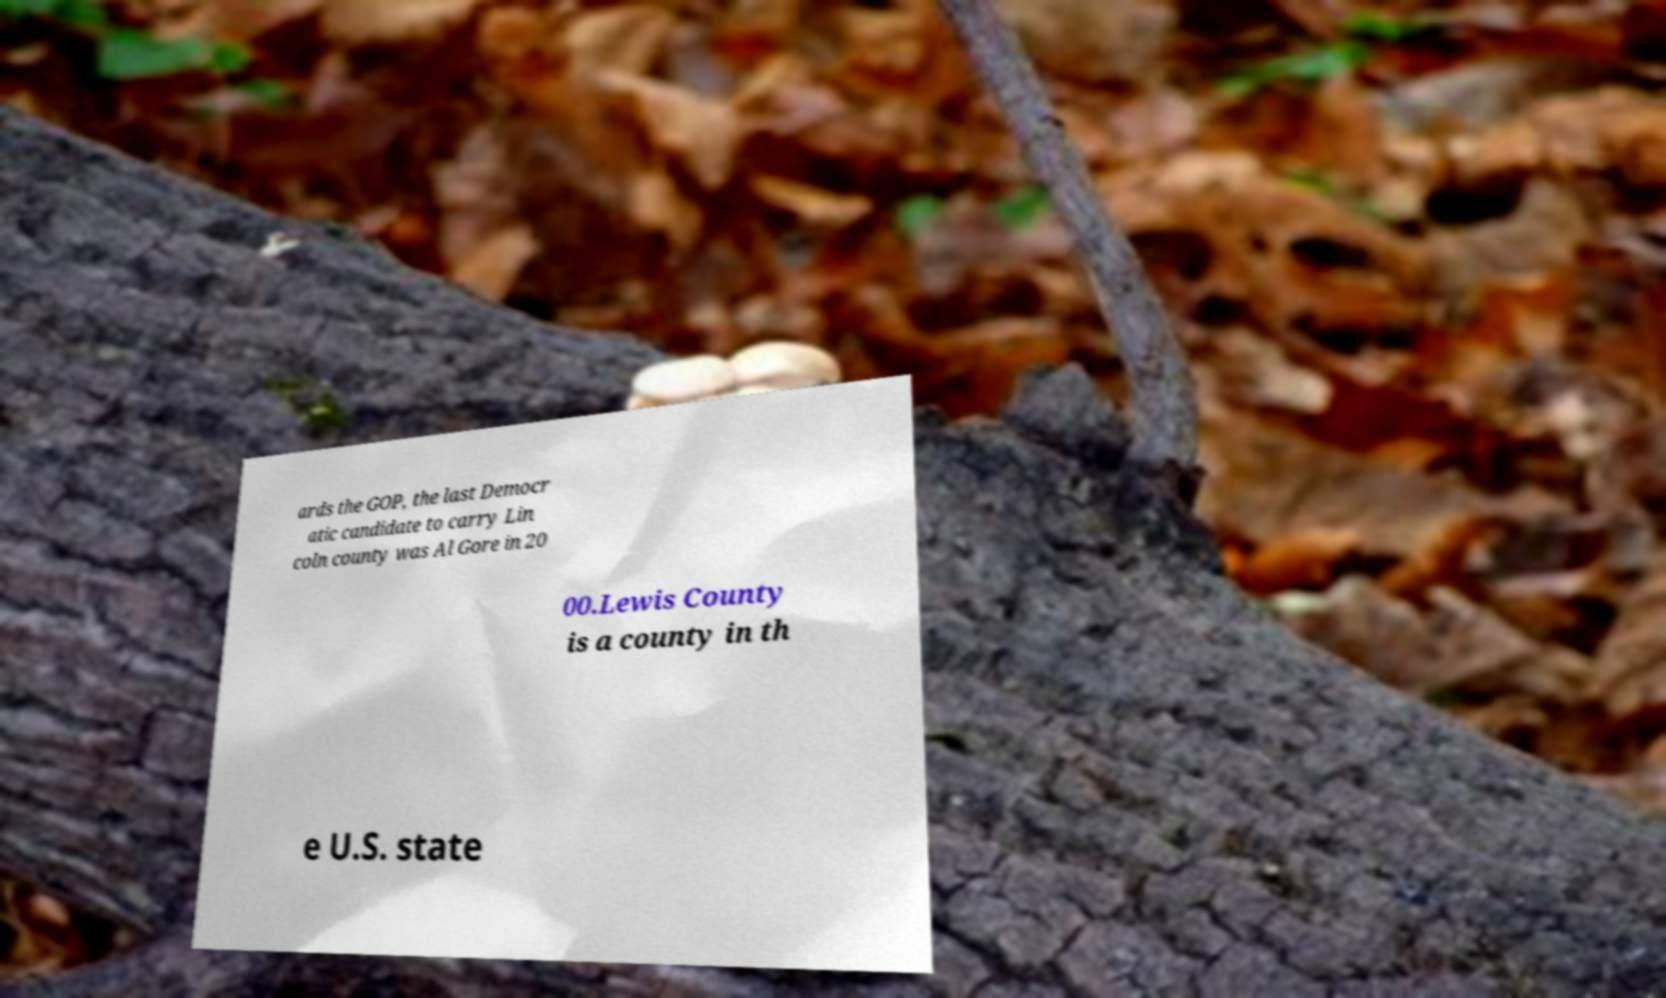Can you accurately transcribe the text from the provided image for me? ards the GOP, the last Democr atic candidate to carry Lin coln county was Al Gore in 20 00.Lewis County is a county in th e U.S. state 